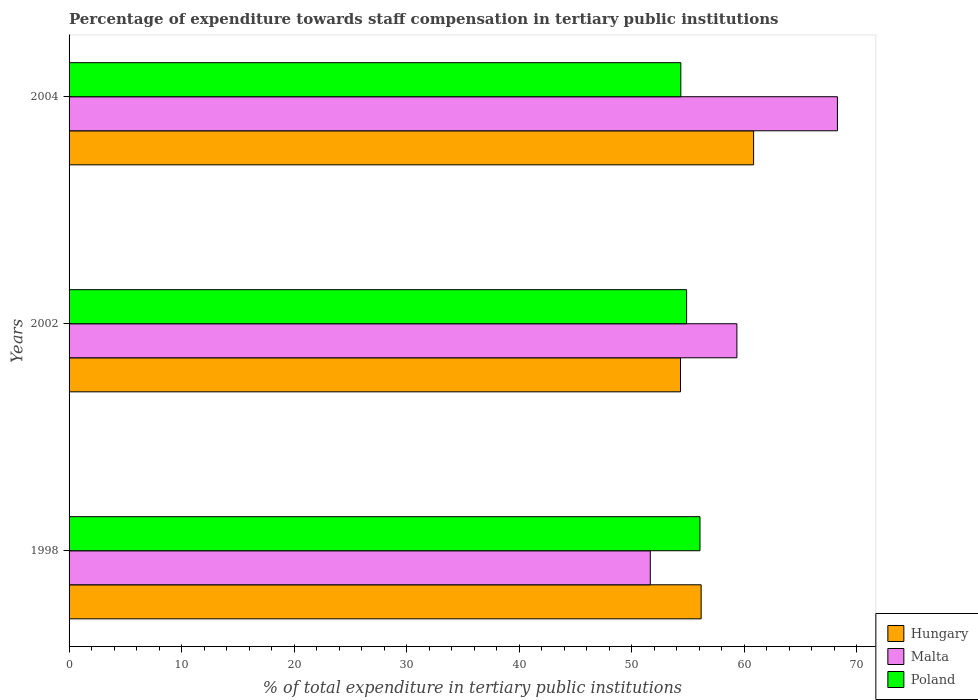Are the number of bars per tick equal to the number of legend labels?
Your answer should be very brief. Yes. Are the number of bars on each tick of the Y-axis equal?
Make the answer very short. Yes. How many bars are there on the 2nd tick from the top?
Your answer should be compact. 3. What is the percentage of expenditure towards staff compensation in Malta in 2002?
Offer a terse response. 59.36. Across all years, what is the maximum percentage of expenditure towards staff compensation in Poland?
Make the answer very short. 56.07. Across all years, what is the minimum percentage of expenditure towards staff compensation in Malta?
Your response must be concise. 51.66. In which year was the percentage of expenditure towards staff compensation in Hungary maximum?
Keep it short and to the point. 2004. What is the total percentage of expenditure towards staff compensation in Poland in the graph?
Offer a very short reply. 165.33. What is the difference between the percentage of expenditure towards staff compensation in Poland in 1998 and that in 2002?
Your answer should be compact. 1.19. What is the difference between the percentage of expenditure towards staff compensation in Poland in 2004 and the percentage of expenditure towards staff compensation in Hungary in 2002?
Your response must be concise. 0.03. What is the average percentage of expenditure towards staff compensation in Hungary per year?
Keep it short and to the point. 57.12. In the year 2002, what is the difference between the percentage of expenditure towards staff compensation in Hungary and percentage of expenditure towards staff compensation in Malta?
Make the answer very short. -5.01. What is the ratio of the percentage of expenditure towards staff compensation in Hungary in 2002 to that in 2004?
Keep it short and to the point. 0.89. Is the difference between the percentage of expenditure towards staff compensation in Hungary in 1998 and 2004 greater than the difference between the percentage of expenditure towards staff compensation in Malta in 1998 and 2004?
Give a very brief answer. Yes. What is the difference between the highest and the second highest percentage of expenditure towards staff compensation in Hungary?
Your answer should be very brief. 4.66. What is the difference between the highest and the lowest percentage of expenditure towards staff compensation in Hungary?
Make the answer very short. 6.5. In how many years, is the percentage of expenditure towards staff compensation in Poland greater than the average percentage of expenditure towards staff compensation in Poland taken over all years?
Give a very brief answer. 1. What does the 3rd bar from the top in 2004 represents?
Give a very brief answer. Hungary. Is it the case that in every year, the sum of the percentage of expenditure towards staff compensation in Malta and percentage of expenditure towards staff compensation in Hungary is greater than the percentage of expenditure towards staff compensation in Poland?
Keep it short and to the point. Yes. How many bars are there?
Your response must be concise. 9. Are all the bars in the graph horizontal?
Your response must be concise. Yes. Are the values on the major ticks of X-axis written in scientific E-notation?
Your response must be concise. No. Does the graph contain grids?
Provide a succinct answer. No. Where does the legend appear in the graph?
Offer a terse response. Bottom right. How are the legend labels stacked?
Ensure brevity in your answer.  Vertical. What is the title of the graph?
Your answer should be very brief. Percentage of expenditure towards staff compensation in tertiary public institutions. What is the label or title of the X-axis?
Provide a short and direct response. % of total expenditure in tertiary public institutions. What is the % of total expenditure in tertiary public institutions in Hungary in 1998?
Keep it short and to the point. 56.18. What is the % of total expenditure in tertiary public institutions of Malta in 1998?
Make the answer very short. 51.66. What is the % of total expenditure in tertiary public institutions in Poland in 1998?
Offer a terse response. 56.07. What is the % of total expenditure in tertiary public institutions of Hungary in 2002?
Your answer should be compact. 54.34. What is the % of total expenditure in tertiary public institutions of Malta in 2002?
Ensure brevity in your answer.  59.36. What is the % of total expenditure in tertiary public institutions in Poland in 2002?
Offer a terse response. 54.89. What is the % of total expenditure in tertiary public institutions in Hungary in 2004?
Make the answer very short. 60.84. What is the % of total expenditure in tertiary public institutions of Malta in 2004?
Give a very brief answer. 68.29. What is the % of total expenditure in tertiary public institutions in Poland in 2004?
Offer a terse response. 54.37. Across all years, what is the maximum % of total expenditure in tertiary public institutions in Hungary?
Keep it short and to the point. 60.84. Across all years, what is the maximum % of total expenditure in tertiary public institutions in Malta?
Offer a terse response. 68.29. Across all years, what is the maximum % of total expenditure in tertiary public institutions of Poland?
Keep it short and to the point. 56.07. Across all years, what is the minimum % of total expenditure in tertiary public institutions in Hungary?
Offer a very short reply. 54.34. Across all years, what is the minimum % of total expenditure in tertiary public institutions in Malta?
Provide a short and direct response. 51.66. Across all years, what is the minimum % of total expenditure in tertiary public institutions in Poland?
Give a very brief answer. 54.37. What is the total % of total expenditure in tertiary public institutions in Hungary in the graph?
Offer a terse response. 171.36. What is the total % of total expenditure in tertiary public institutions of Malta in the graph?
Provide a succinct answer. 179.3. What is the total % of total expenditure in tertiary public institutions in Poland in the graph?
Provide a succinct answer. 165.33. What is the difference between the % of total expenditure in tertiary public institutions in Hungary in 1998 and that in 2002?
Your response must be concise. 1.83. What is the difference between the % of total expenditure in tertiary public institutions of Malta in 1998 and that in 2002?
Offer a terse response. -7.7. What is the difference between the % of total expenditure in tertiary public institutions in Poland in 1998 and that in 2002?
Give a very brief answer. 1.19. What is the difference between the % of total expenditure in tertiary public institutions of Hungary in 1998 and that in 2004?
Give a very brief answer. -4.66. What is the difference between the % of total expenditure in tertiary public institutions of Malta in 1998 and that in 2004?
Provide a succinct answer. -16.63. What is the difference between the % of total expenditure in tertiary public institutions in Poland in 1998 and that in 2004?
Your answer should be very brief. 1.7. What is the difference between the % of total expenditure in tertiary public institutions of Hungary in 2002 and that in 2004?
Provide a succinct answer. -6.5. What is the difference between the % of total expenditure in tertiary public institutions in Malta in 2002 and that in 2004?
Your answer should be very brief. -8.93. What is the difference between the % of total expenditure in tertiary public institutions in Poland in 2002 and that in 2004?
Keep it short and to the point. 0.51. What is the difference between the % of total expenditure in tertiary public institutions of Hungary in 1998 and the % of total expenditure in tertiary public institutions of Malta in 2002?
Keep it short and to the point. -3.18. What is the difference between the % of total expenditure in tertiary public institutions of Hungary in 1998 and the % of total expenditure in tertiary public institutions of Poland in 2002?
Your response must be concise. 1.29. What is the difference between the % of total expenditure in tertiary public institutions of Malta in 1998 and the % of total expenditure in tertiary public institutions of Poland in 2002?
Keep it short and to the point. -3.23. What is the difference between the % of total expenditure in tertiary public institutions in Hungary in 1998 and the % of total expenditure in tertiary public institutions in Malta in 2004?
Keep it short and to the point. -12.11. What is the difference between the % of total expenditure in tertiary public institutions of Hungary in 1998 and the % of total expenditure in tertiary public institutions of Poland in 2004?
Keep it short and to the point. 1.81. What is the difference between the % of total expenditure in tertiary public institutions in Malta in 1998 and the % of total expenditure in tertiary public institutions in Poland in 2004?
Keep it short and to the point. -2.71. What is the difference between the % of total expenditure in tertiary public institutions of Hungary in 2002 and the % of total expenditure in tertiary public institutions of Malta in 2004?
Offer a terse response. -13.95. What is the difference between the % of total expenditure in tertiary public institutions in Hungary in 2002 and the % of total expenditure in tertiary public institutions in Poland in 2004?
Keep it short and to the point. -0.03. What is the difference between the % of total expenditure in tertiary public institutions in Malta in 2002 and the % of total expenditure in tertiary public institutions in Poland in 2004?
Give a very brief answer. 4.98. What is the average % of total expenditure in tertiary public institutions in Hungary per year?
Your answer should be very brief. 57.12. What is the average % of total expenditure in tertiary public institutions of Malta per year?
Give a very brief answer. 59.77. What is the average % of total expenditure in tertiary public institutions of Poland per year?
Your response must be concise. 55.11. In the year 1998, what is the difference between the % of total expenditure in tertiary public institutions in Hungary and % of total expenditure in tertiary public institutions in Malta?
Make the answer very short. 4.52. In the year 1998, what is the difference between the % of total expenditure in tertiary public institutions in Hungary and % of total expenditure in tertiary public institutions in Poland?
Your response must be concise. 0.1. In the year 1998, what is the difference between the % of total expenditure in tertiary public institutions of Malta and % of total expenditure in tertiary public institutions of Poland?
Offer a terse response. -4.42. In the year 2002, what is the difference between the % of total expenditure in tertiary public institutions of Hungary and % of total expenditure in tertiary public institutions of Malta?
Your answer should be compact. -5.01. In the year 2002, what is the difference between the % of total expenditure in tertiary public institutions in Hungary and % of total expenditure in tertiary public institutions in Poland?
Provide a short and direct response. -0.54. In the year 2002, what is the difference between the % of total expenditure in tertiary public institutions in Malta and % of total expenditure in tertiary public institutions in Poland?
Make the answer very short. 4.47. In the year 2004, what is the difference between the % of total expenditure in tertiary public institutions in Hungary and % of total expenditure in tertiary public institutions in Malta?
Your response must be concise. -7.45. In the year 2004, what is the difference between the % of total expenditure in tertiary public institutions in Hungary and % of total expenditure in tertiary public institutions in Poland?
Offer a terse response. 6.47. In the year 2004, what is the difference between the % of total expenditure in tertiary public institutions of Malta and % of total expenditure in tertiary public institutions of Poland?
Provide a succinct answer. 13.92. What is the ratio of the % of total expenditure in tertiary public institutions in Hungary in 1998 to that in 2002?
Your answer should be compact. 1.03. What is the ratio of the % of total expenditure in tertiary public institutions of Malta in 1998 to that in 2002?
Make the answer very short. 0.87. What is the ratio of the % of total expenditure in tertiary public institutions in Poland in 1998 to that in 2002?
Provide a short and direct response. 1.02. What is the ratio of the % of total expenditure in tertiary public institutions in Hungary in 1998 to that in 2004?
Your answer should be very brief. 0.92. What is the ratio of the % of total expenditure in tertiary public institutions of Malta in 1998 to that in 2004?
Keep it short and to the point. 0.76. What is the ratio of the % of total expenditure in tertiary public institutions of Poland in 1998 to that in 2004?
Your response must be concise. 1.03. What is the ratio of the % of total expenditure in tertiary public institutions in Hungary in 2002 to that in 2004?
Your answer should be very brief. 0.89. What is the ratio of the % of total expenditure in tertiary public institutions of Malta in 2002 to that in 2004?
Provide a short and direct response. 0.87. What is the ratio of the % of total expenditure in tertiary public institutions in Poland in 2002 to that in 2004?
Ensure brevity in your answer.  1.01. What is the difference between the highest and the second highest % of total expenditure in tertiary public institutions in Hungary?
Provide a succinct answer. 4.66. What is the difference between the highest and the second highest % of total expenditure in tertiary public institutions of Malta?
Ensure brevity in your answer.  8.93. What is the difference between the highest and the second highest % of total expenditure in tertiary public institutions in Poland?
Your answer should be compact. 1.19. What is the difference between the highest and the lowest % of total expenditure in tertiary public institutions of Hungary?
Offer a very short reply. 6.5. What is the difference between the highest and the lowest % of total expenditure in tertiary public institutions of Malta?
Provide a short and direct response. 16.63. What is the difference between the highest and the lowest % of total expenditure in tertiary public institutions in Poland?
Ensure brevity in your answer.  1.7. 